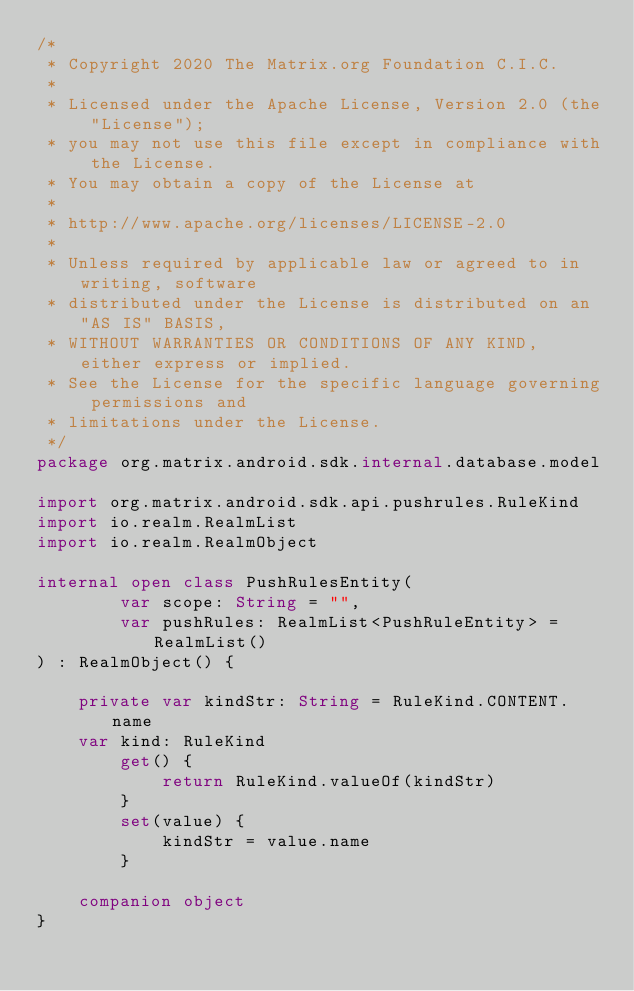Convert code to text. <code><loc_0><loc_0><loc_500><loc_500><_Kotlin_>/*
 * Copyright 2020 The Matrix.org Foundation C.I.C.
 *
 * Licensed under the Apache License, Version 2.0 (the "License");
 * you may not use this file except in compliance with the License.
 * You may obtain a copy of the License at
 *
 * http://www.apache.org/licenses/LICENSE-2.0
 *
 * Unless required by applicable law or agreed to in writing, software
 * distributed under the License is distributed on an "AS IS" BASIS,
 * WITHOUT WARRANTIES OR CONDITIONS OF ANY KIND, either express or implied.
 * See the License for the specific language governing permissions and
 * limitations under the License.
 */
package org.matrix.android.sdk.internal.database.model

import org.matrix.android.sdk.api.pushrules.RuleKind
import io.realm.RealmList
import io.realm.RealmObject

internal open class PushRulesEntity(
        var scope: String = "",
        var pushRules: RealmList<PushRuleEntity> = RealmList()
) : RealmObject() {

    private var kindStr: String = RuleKind.CONTENT.name
    var kind: RuleKind
        get() {
            return RuleKind.valueOf(kindStr)
        }
        set(value) {
            kindStr = value.name
        }

    companion object
}
</code> 